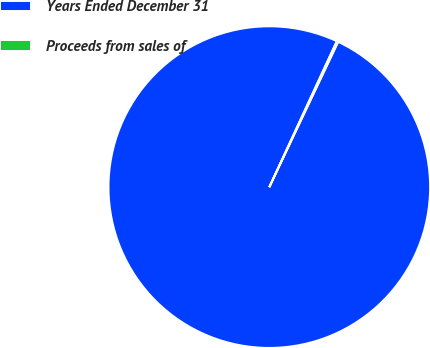Convert chart to OTSL. <chart><loc_0><loc_0><loc_500><loc_500><pie_chart><fcel>Years Ended December 31<fcel>Proceeds from sales of<nl><fcel>99.85%<fcel>0.15%<nl></chart> 